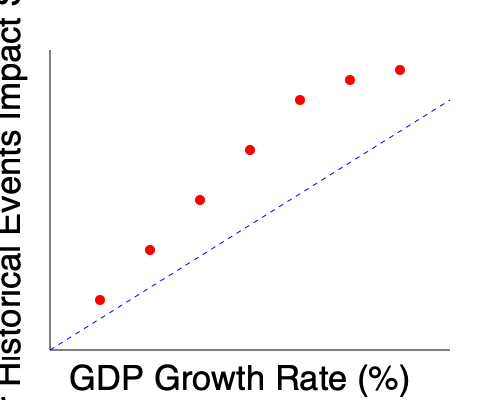Based on the scatter plot showing the correlation between GDP growth rate and the impact score of major historical events, what type of relationship is depicted, and how might this inform our understanding of economic influences on historical turning points? To answer this question, let's analyze the scatter plot step by step:

1. Observe the overall trend: The data points generally move from the bottom-right to the top-left of the graph.

2. Identify the variables:
   - X-axis: GDP Growth Rate (%)
   - Y-axis: Major Historical Events Impact Score

3. Analyze the relationship:
   - As the GDP Growth Rate increases, the Major Historical Events Impact Score tends to decrease.
   - This suggests a negative or inverse relationship between the two variables.

4. Assess the strength of the relationship:
   - The points roughly follow a linear pattern, indicating a moderately strong correlation.
   - The blue dashed line represents the general trend, further emphasizing this relationship.

5. Interpret the relationship:
   - Higher GDP growth rates are associated with lower impact scores of major historical events.
   - Conversely, lower GDP growth rates correspond to higher impact scores.

6. Historical context:
   - This relationship suggests that periods of economic prosperity (high GDP growth) may lead to fewer impactful historical events.
   - Conversely, periods of economic hardship or slow growth may be more likely to coincide with significant historical turning points.

7. Implications for historical analysis:
   - Historians should consider economic factors when studying the causes and contexts of major historical events.
   - The relationship shown in the graph supports the idea that economic conditions can be a driving force behind historical change.

8. Limitations:
   - Correlation does not imply causation; other factors may influence both variables.
   - The relationship shown is a general trend and may not apply to all specific cases.

Given this analysis, we can conclude that the scatter plot depicts a negative correlation between GDP growth rate and the impact of major historical events, suggesting that economic factors play a significant role in shaping historical turning points.
Answer: Negative correlation; economic prosperity may reduce likelihood of major historical events. 